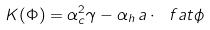Convert formula to latex. <formula><loc_0><loc_0><loc_500><loc_500>K ( \Phi ) = \alpha _ { c } ^ { 2 } \gamma - \alpha _ { h } \, a \cdot { \ f a t \phi }</formula> 